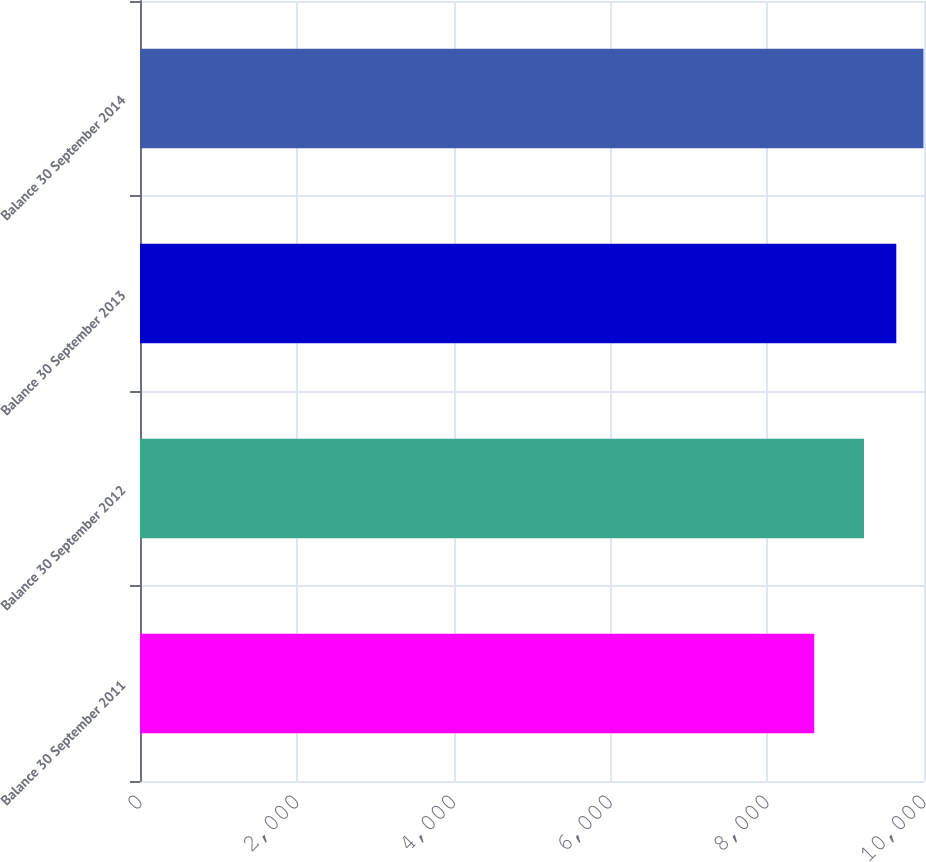Convert chart to OTSL. <chart><loc_0><loc_0><loc_500><loc_500><bar_chart><fcel>Balance 30 September 2011<fcel>Balance 30 September 2012<fcel>Balance 30 September 2013<fcel>Balance 30 September 2014<nl><fcel>8599.5<fcel>9234.5<fcel>9646.4<fcel>9993.2<nl></chart> 